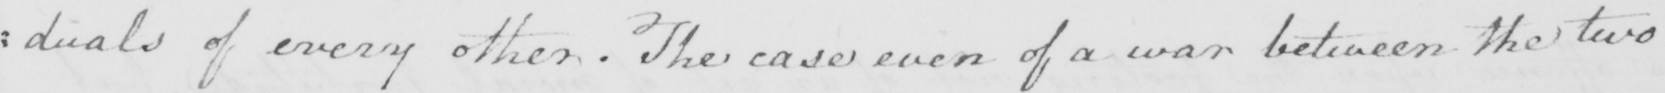Please transcribe the handwritten text in this image. : duals of every other . The case even of a war between the two 